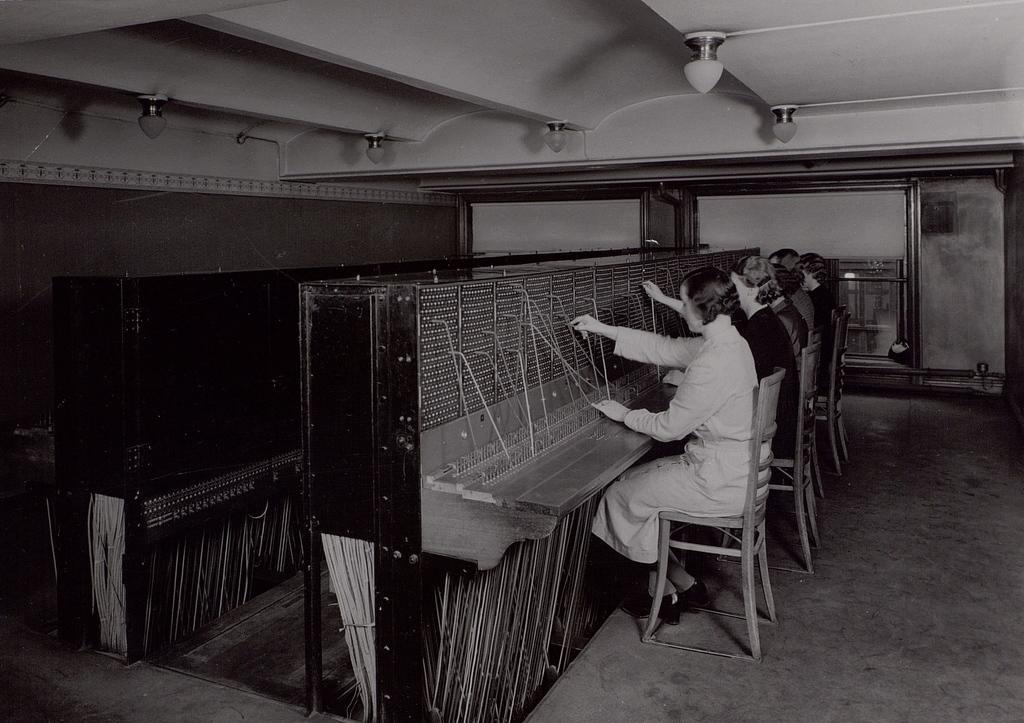Could you give a brief overview of what you see in this image? In this image there are a few people sitting on the chairs and working on one of the machines, there are lights to the roof and reflections on the glass door. 